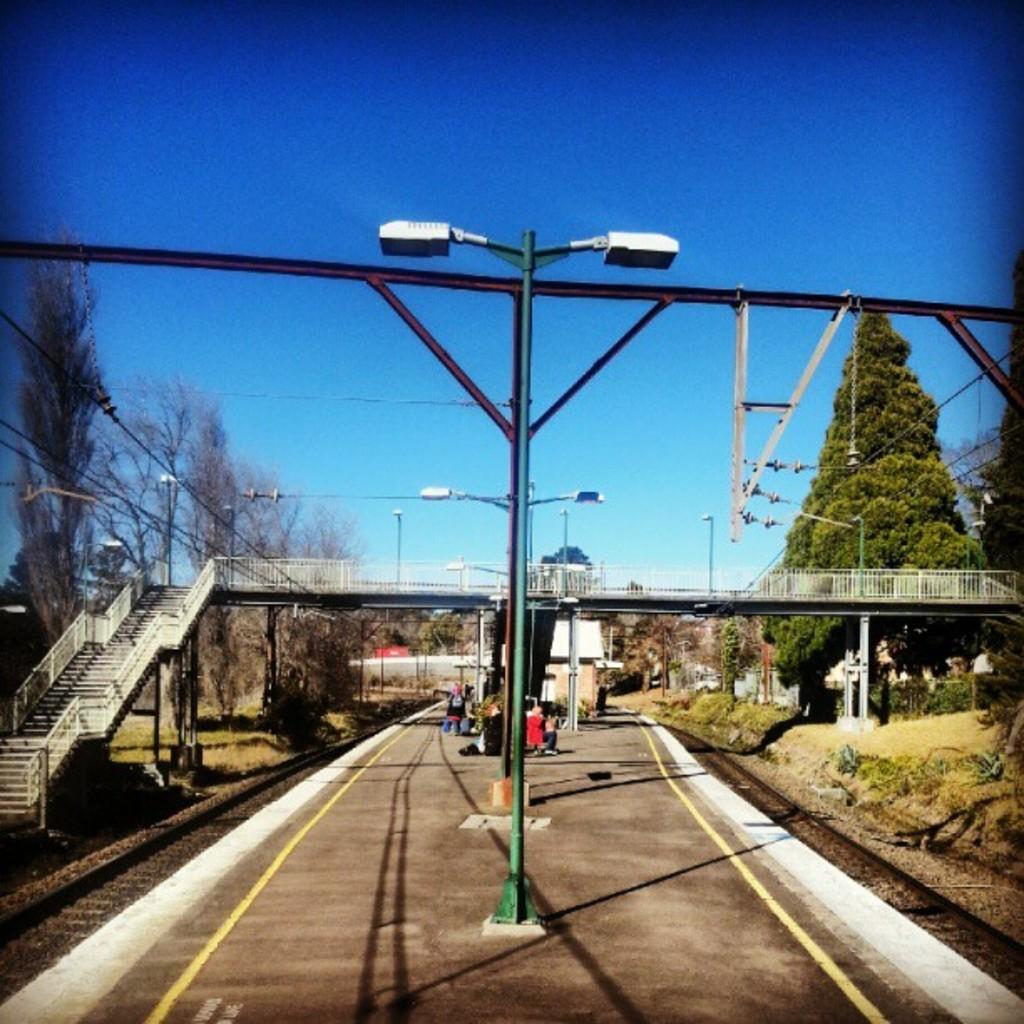What is the main structure in the image? There is a platform in the image. What is located near the platform? There is a railway track in the image. What type of lighting is present in the image? Street lights are visible in the image. What else can be seen in the image related to infrastructure? Cable wires, a railing, and a bridge are present in the image. What type of vegetation is visible in the image? Grass, plants, and trees are present in the image. What is the sky's condition in the image? The sky is visible at the top of the image. Can you describe the fight between the two trees in the image? There is no fight between any trees in the image; the trees are simply standing in the background. How does the end of the bridge affect the image? The end of the bridge is not mentioned in the provided facts, so it cannot be determined how it affects the image. 